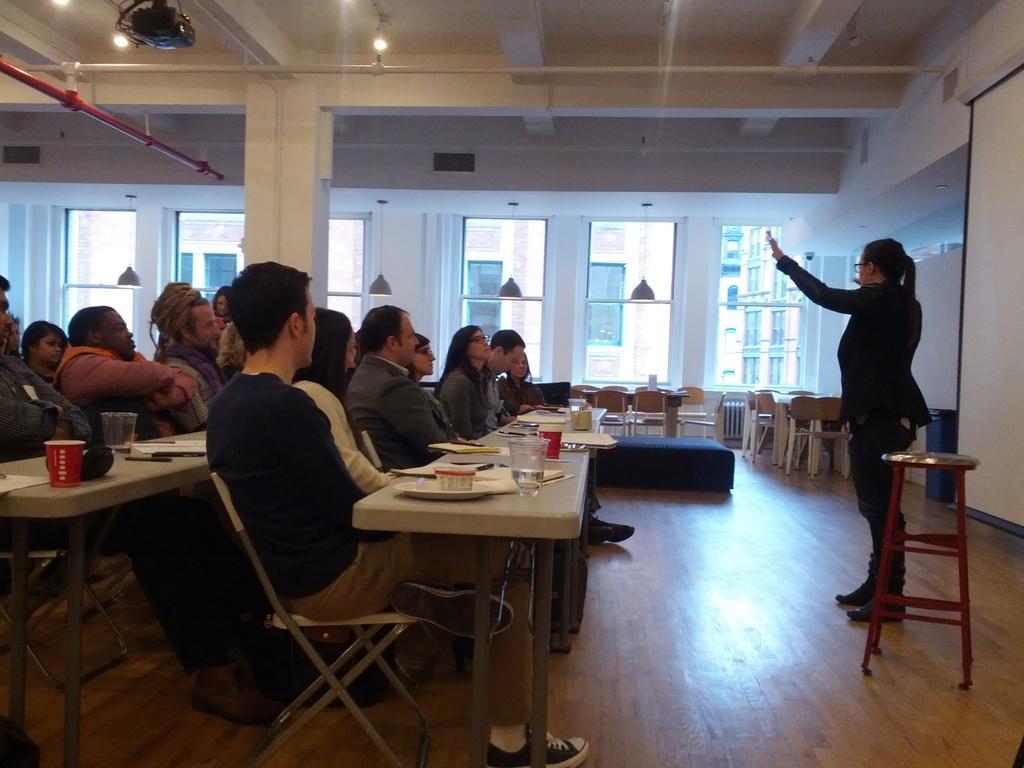Describe this image in one or two sentences. It looks like the image is clicked in a class room. There are many people sitting in the chairs near the tables. To the right, there is woman wearing black dress and standing, behind her there is a screen. In the background, there are windows and pillar. 